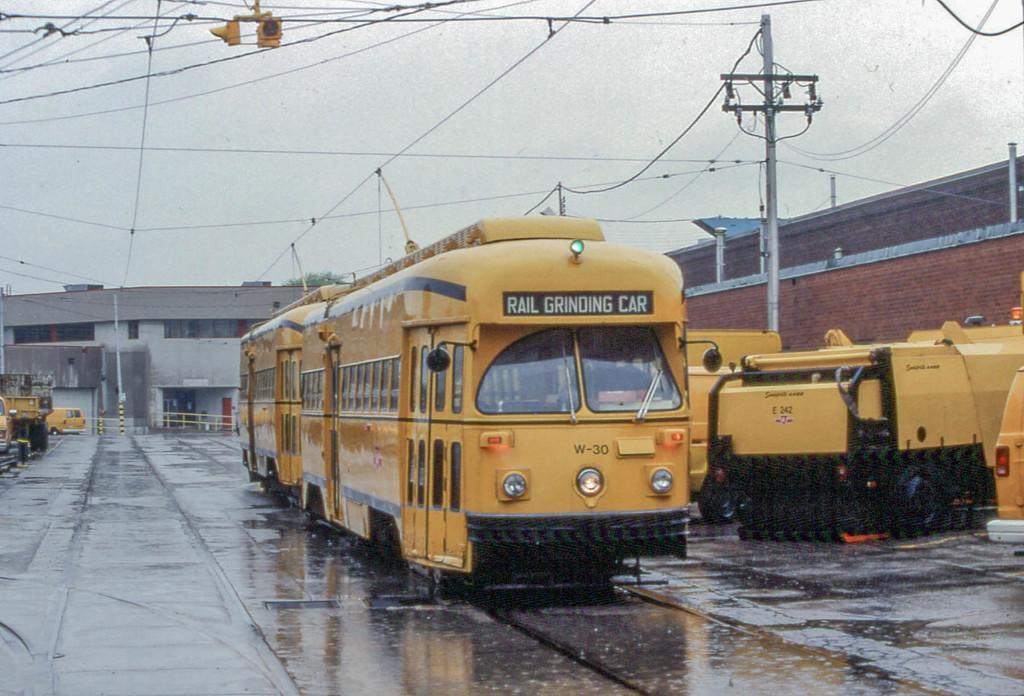Could you give a brief overview of what you see in this image? In the picture we can see a train which is yellow in color on the track, just beside to it, we can see some vehicles and house buildings, in the background also we can see some buildings and some poles and we can also see a sky. 